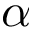<formula> <loc_0><loc_0><loc_500><loc_500>\alpha</formula> 